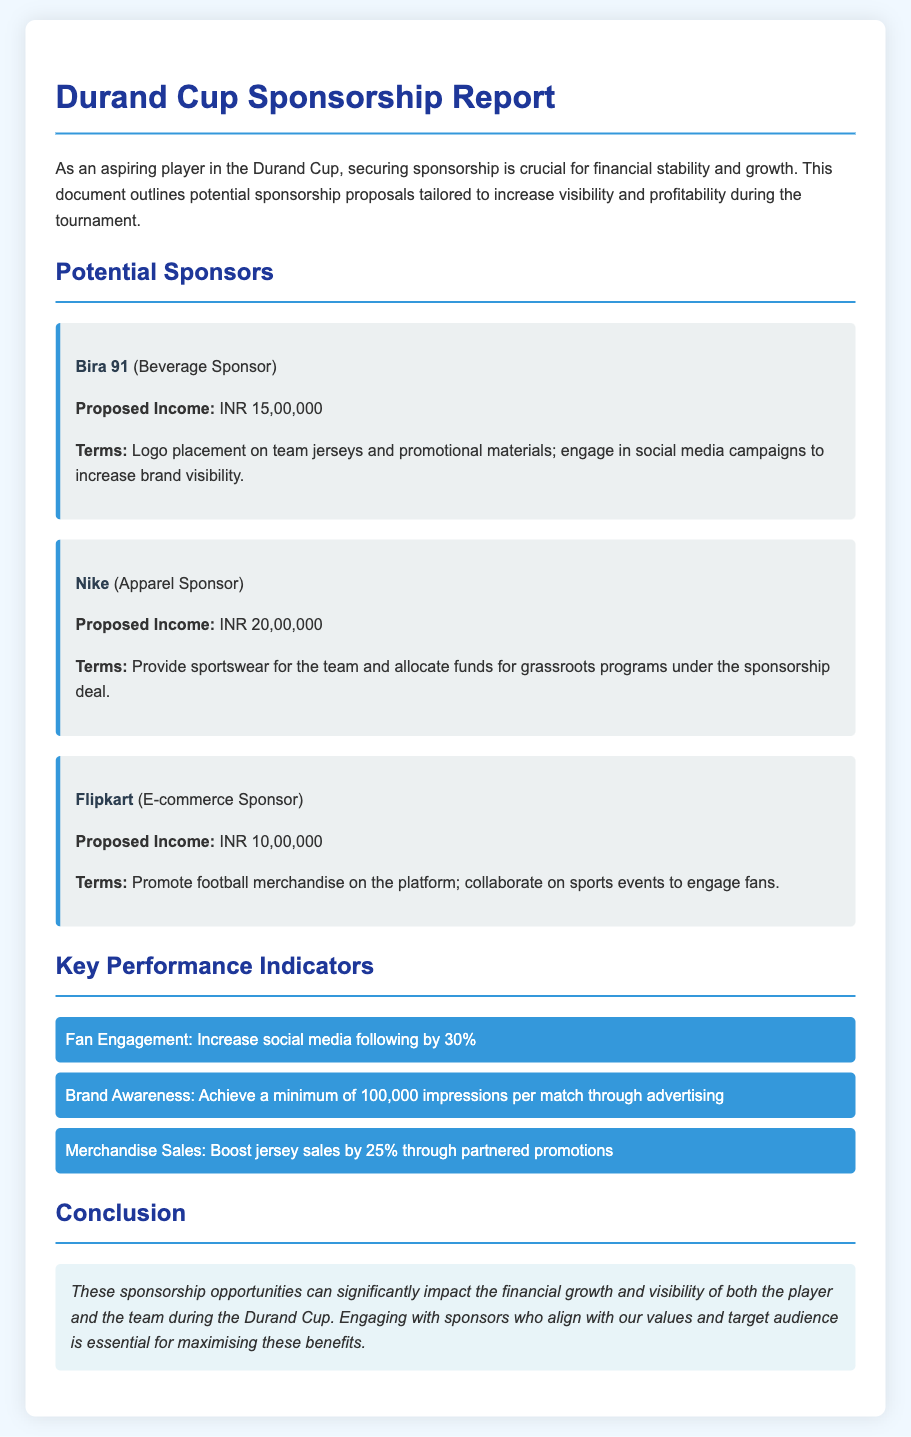What is the proposed income from Bira 91? The proposed income from Bira 91, the beverage sponsor, is specified in the document.
Answer: INR 15,00,000 What is the proposed income from Nike? The document states the proposed income that Nike, the apparel sponsor, is offering.
Answer: INR 20,00,000 How much is the proposed income from Flipkart? According to the document, the proposed income from the E-commerce sponsor, Flipkart, is mentioned.
Answer: INR 10,00,000 What sponsorship term is associated with Bira 91? The document provides details on sponsorship terms, including Bira 91’s specific terms regarding logo placement and promotion.
Answer: Logo placement on team jerseys and promotional materials; engage in social media campaigns to increase brand visibility Which KPI indicates fan engagement? The document lists several key performance indicators (KPIs), highlighting the KPI focused on increasing social media following.
Answer: Increase social media following by 30% How many impressions per match are targeted for brand awareness? The document states the target for impressions that contribute to brand awareness by discussing advertising reaches.
Answer: 100,000 impressions per match What is the goal for merchandise sales increase? The document outlines a KPI that specifies the targeted increase in jersey sales through promotions.
Answer: Boost jersey sales by 25% What is the overall conclusion drawn in the document? The conclusion emphasizes the importance of sponsorship opportunities for financial growth during the tournament, relating it to both player and team benefits.
Answer: Sponsorship opportunities can significantly impact the financial growth and visibility of both the player and the team during the Durand Cup 